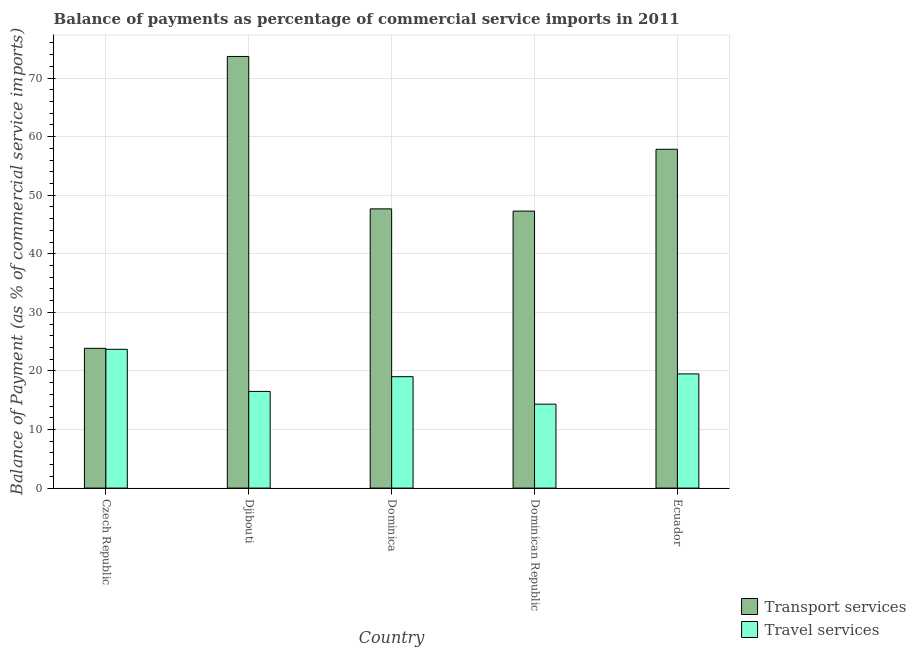How many different coloured bars are there?
Make the answer very short. 2. How many groups of bars are there?
Give a very brief answer. 5. Are the number of bars on each tick of the X-axis equal?
Your response must be concise. Yes. How many bars are there on the 4th tick from the right?
Keep it short and to the point. 2. What is the label of the 5th group of bars from the left?
Offer a very short reply. Ecuador. What is the balance of payments of travel services in Djibouti?
Keep it short and to the point. 16.5. Across all countries, what is the maximum balance of payments of transport services?
Ensure brevity in your answer.  73.68. Across all countries, what is the minimum balance of payments of travel services?
Keep it short and to the point. 14.33. In which country was the balance of payments of travel services maximum?
Your answer should be compact. Czech Republic. In which country was the balance of payments of travel services minimum?
Keep it short and to the point. Dominican Republic. What is the total balance of payments of transport services in the graph?
Your response must be concise. 250.31. What is the difference between the balance of payments of transport services in Czech Republic and that in Ecuador?
Your answer should be compact. -33.98. What is the difference between the balance of payments of travel services in Djibouti and the balance of payments of transport services in Dominican Republic?
Make the answer very short. -30.78. What is the average balance of payments of travel services per country?
Provide a short and direct response. 18.61. What is the difference between the balance of payments of transport services and balance of payments of travel services in Ecuador?
Your answer should be very brief. 38.34. What is the ratio of the balance of payments of travel services in Dominican Republic to that in Ecuador?
Make the answer very short. 0.74. Is the balance of payments of transport services in Dominica less than that in Ecuador?
Provide a short and direct response. Yes. What is the difference between the highest and the second highest balance of payments of transport services?
Keep it short and to the point. 15.84. What is the difference between the highest and the lowest balance of payments of travel services?
Offer a very short reply. 9.37. What does the 1st bar from the left in Ecuador represents?
Provide a short and direct response. Transport services. What does the 2nd bar from the right in Djibouti represents?
Make the answer very short. Transport services. How many countries are there in the graph?
Offer a very short reply. 5. What is the difference between two consecutive major ticks on the Y-axis?
Your response must be concise. 10. Does the graph contain grids?
Offer a terse response. Yes. How many legend labels are there?
Provide a short and direct response. 2. How are the legend labels stacked?
Make the answer very short. Vertical. What is the title of the graph?
Your answer should be very brief. Balance of payments as percentage of commercial service imports in 2011. What is the label or title of the Y-axis?
Your answer should be very brief. Balance of Payment (as % of commercial service imports). What is the Balance of Payment (as % of commercial service imports) in Transport services in Czech Republic?
Provide a succinct answer. 23.86. What is the Balance of Payment (as % of commercial service imports) in Travel services in Czech Republic?
Your response must be concise. 23.69. What is the Balance of Payment (as % of commercial service imports) of Transport services in Djibouti?
Offer a very short reply. 73.68. What is the Balance of Payment (as % of commercial service imports) of Travel services in Djibouti?
Offer a terse response. 16.5. What is the Balance of Payment (as % of commercial service imports) of Transport services in Dominica?
Offer a terse response. 47.66. What is the Balance of Payment (as % of commercial service imports) in Travel services in Dominica?
Give a very brief answer. 19.02. What is the Balance of Payment (as % of commercial service imports) of Transport services in Dominican Republic?
Your response must be concise. 47.28. What is the Balance of Payment (as % of commercial service imports) in Travel services in Dominican Republic?
Your answer should be very brief. 14.33. What is the Balance of Payment (as % of commercial service imports) in Transport services in Ecuador?
Offer a terse response. 57.83. What is the Balance of Payment (as % of commercial service imports) in Travel services in Ecuador?
Offer a very short reply. 19.49. Across all countries, what is the maximum Balance of Payment (as % of commercial service imports) of Transport services?
Give a very brief answer. 73.68. Across all countries, what is the maximum Balance of Payment (as % of commercial service imports) in Travel services?
Ensure brevity in your answer.  23.69. Across all countries, what is the minimum Balance of Payment (as % of commercial service imports) of Transport services?
Your response must be concise. 23.86. Across all countries, what is the minimum Balance of Payment (as % of commercial service imports) in Travel services?
Offer a very short reply. 14.33. What is the total Balance of Payment (as % of commercial service imports) in Transport services in the graph?
Your response must be concise. 250.31. What is the total Balance of Payment (as % of commercial service imports) of Travel services in the graph?
Your answer should be very brief. 93.03. What is the difference between the Balance of Payment (as % of commercial service imports) of Transport services in Czech Republic and that in Djibouti?
Offer a terse response. -49.82. What is the difference between the Balance of Payment (as % of commercial service imports) in Travel services in Czech Republic and that in Djibouti?
Keep it short and to the point. 7.19. What is the difference between the Balance of Payment (as % of commercial service imports) of Transport services in Czech Republic and that in Dominica?
Make the answer very short. -23.8. What is the difference between the Balance of Payment (as % of commercial service imports) of Travel services in Czech Republic and that in Dominica?
Your answer should be compact. 4.67. What is the difference between the Balance of Payment (as % of commercial service imports) of Transport services in Czech Republic and that in Dominican Republic?
Ensure brevity in your answer.  -23.42. What is the difference between the Balance of Payment (as % of commercial service imports) of Travel services in Czech Republic and that in Dominican Republic?
Ensure brevity in your answer.  9.37. What is the difference between the Balance of Payment (as % of commercial service imports) of Transport services in Czech Republic and that in Ecuador?
Your answer should be very brief. -33.98. What is the difference between the Balance of Payment (as % of commercial service imports) of Travel services in Czech Republic and that in Ecuador?
Make the answer very short. 4.2. What is the difference between the Balance of Payment (as % of commercial service imports) in Transport services in Djibouti and that in Dominica?
Provide a succinct answer. 26.02. What is the difference between the Balance of Payment (as % of commercial service imports) of Travel services in Djibouti and that in Dominica?
Provide a succinct answer. -2.51. What is the difference between the Balance of Payment (as % of commercial service imports) in Transport services in Djibouti and that in Dominican Republic?
Provide a succinct answer. 26.4. What is the difference between the Balance of Payment (as % of commercial service imports) of Travel services in Djibouti and that in Dominican Republic?
Offer a terse response. 2.18. What is the difference between the Balance of Payment (as % of commercial service imports) of Transport services in Djibouti and that in Ecuador?
Offer a very short reply. 15.84. What is the difference between the Balance of Payment (as % of commercial service imports) in Travel services in Djibouti and that in Ecuador?
Provide a succinct answer. -2.99. What is the difference between the Balance of Payment (as % of commercial service imports) of Transport services in Dominica and that in Dominican Republic?
Ensure brevity in your answer.  0.38. What is the difference between the Balance of Payment (as % of commercial service imports) in Travel services in Dominica and that in Dominican Republic?
Your response must be concise. 4.69. What is the difference between the Balance of Payment (as % of commercial service imports) of Transport services in Dominica and that in Ecuador?
Keep it short and to the point. -10.17. What is the difference between the Balance of Payment (as % of commercial service imports) in Travel services in Dominica and that in Ecuador?
Your answer should be compact. -0.47. What is the difference between the Balance of Payment (as % of commercial service imports) of Transport services in Dominican Republic and that in Ecuador?
Make the answer very short. -10.55. What is the difference between the Balance of Payment (as % of commercial service imports) in Travel services in Dominican Republic and that in Ecuador?
Your response must be concise. -5.16. What is the difference between the Balance of Payment (as % of commercial service imports) of Transport services in Czech Republic and the Balance of Payment (as % of commercial service imports) of Travel services in Djibouti?
Keep it short and to the point. 7.36. What is the difference between the Balance of Payment (as % of commercial service imports) of Transport services in Czech Republic and the Balance of Payment (as % of commercial service imports) of Travel services in Dominica?
Your answer should be compact. 4.84. What is the difference between the Balance of Payment (as % of commercial service imports) in Transport services in Czech Republic and the Balance of Payment (as % of commercial service imports) in Travel services in Dominican Republic?
Give a very brief answer. 9.53. What is the difference between the Balance of Payment (as % of commercial service imports) of Transport services in Czech Republic and the Balance of Payment (as % of commercial service imports) of Travel services in Ecuador?
Your response must be concise. 4.37. What is the difference between the Balance of Payment (as % of commercial service imports) of Transport services in Djibouti and the Balance of Payment (as % of commercial service imports) of Travel services in Dominica?
Provide a short and direct response. 54.66. What is the difference between the Balance of Payment (as % of commercial service imports) in Transport services in Djibouti and the Balance of Payment (as % of commercial service imports) in Travel services in Dominican Republic?
Ensure brevity in your answer.  59.35. What is the difference between the Balance of Payment (as % of commercial service imports) in Transport services in Djibouti and the Balance of Payment (as % of commercial service imports) in Travel services in Ecuador?
Provide a succinct answer. 54.19. What is the difference between the Balance of Payment (as % of commercial service imports) of Transport services in Dominica and the Balance of Payment (as % of commercial service imports) of Travel services in Dominican Republic?
Offer a terse response. 33.34. What is the difference between the Balance of Payment (as % of commercial service imports) of Transport services in Dominica and the Balance of Payment (as % of commercial service imports) of Travel services in Ecuador?
Keep it short and to the point. 28.17. What is the difference between the Balance of Payment (as % of commercial service imports) in Transport services in Dominican Republic and the Balance of Payment (as % of commercial service imports) in Travel services in Ecuador?
Your answer should be very brief. 27.79. What is the average Balance of Payment (as % of commercial service imports) of Transport services per country?
Ensure brevity in your answer.  50.06. What is the average Balance of Payment (as % of commercial service imports) of Travel services per country?
Your answer should be compact. 18.61. What is the difference between the Balance of Payment (as % of commercial service imports) in Transport services and Balance of Payment (as % of commercial service imports) in Travel services in Czech Republic?
Keep it short and to the point. 0.17. What is the difference between the Balance of Payment (as % of commercial service imports) in Transport services and Balance of Payment (as % of commercial service imports) in Travel services in Djibouti?
Ensure brevity in your answer.  57.18. What is the difference between the Balance of Payment (as % of commercial service imports) of Transport services and Balance of Payment (as % of commercial service imports) of Travel services in Dominica?
Offer a terse response. 28.65. What is the difference between the Balance of Payment (as % of commercial service imports) of Transport services and Balance of Payment (as % of commercial service imports) of Travel services in Dominican Republic?
Your answer should be compact. 32.96. What is the difference between the Balance of Payment (as % of commercial service imports) of Transport services and Balance of Payment (as % of commercial service imports) of Travel services in Ecuador?
Your response must be concise. 38.34. What is the ratio of the Balance of Payment (as % of commercial service imports) in Transport services in Czech Republic to that in Djibouti?
Keep it short and to the point. 0.32. What is the ratio of the Balance of Payment (as % of commercial service imports) of Travel services in Czech Republic to that in Djibouti?
Your answer should be compact. 1.44. What is the ratio of the Balance of Payment (as % of commercial service imports) of Transport services in Czech Republic to that in Dominica?
Make the answer very short. 0.5. What is the ratio of the Balance of Payment (as % of commercial service imports) in Travel services in Czech Republic to that in Dominica?
Your answer should be compact. 1.25. What is the ratio of the Balance of Payment (as % of commercial service imports) in Transport services in Czech Republic to that in Dominican Republic?
Offer a terse response. 0.5. What is the ratio of the Balance of Payment (as % of commercial service imports) of Travel services in Czech Republic to that in Dominican Republic?
Keep it short and to the point. 1.65. What is the ratio of the Balance of Payment (as % of commercial service imports) in Transport services in Czech Republic to that in Ecuador?
Your response must be concise. 0.41. What is the ratio of the Balance of Payment (as % of commercial service imports) of Travel services in Czech Republic to that in Ecuador?
Your answer should be very brief. 1.22. What is the ratio of the Balance of Payment (as % of commercial service imports) in Transport services in Djibouti to that in Dominica?
Give a very brief answer. 1.55. What is the ratio of the Balance of Payment (as % of commercial service imports) of Travel services in Djibouti to that in Dominica?
Keep it short and to the point. 0.87. What is the ratio of the Balance of Payment (as % of commercial service imports) in Transport services in Djibouti to that in Dominican Republic?
Make the answer very short. 1.56. What is the ratio of the Balance of Payment (as % of commercial service imports) in Travel services in Djibouti to that in Dominican Republic?
Give a very brief answer. 1.15. What is the ratio of the Balance of Payment (as % of commercial service imports) of Transport services in Djibouti to that in Ecuador?
Keep it short and to the point. 1.27. What is the ratio of the Balance of Payment (as % of commercial service imports) of Travel services in Djibouti to that in Ecuador?
Make the answer very short. 0.85. What is the ratio of the Balance of Payment (as % of commercial service imports) in Transport services in Dominica to that in Dominican Republic?
Your response must be concise. 1.01. What is the ratio of the Balance of Payment (as % of commercial service imports) in Travel services in Dominica to that in Dominican Republic?
Offer a terse response. 1.33. What is the ratio of the Balance of Payment (as % of commercial service imports) of Transport services in Dominica to that in Ecuador?
Your response must be concise. 0.82. What is the ratio of the Balance of Payment (as % of commercial service imports) in Travel services in Dominica to that in Ecuador?
Offer a very short reply. 0.98. What is the ratio of the Balance of Payment (as % of commercial service imports) in Transport services in Dominican Republic to that in Ecuador?
Ensure brevity in your answer.  0.82. What is the ratio of the Balance of Payment (as % of commercial service imports) in Travel services in Dominican Republic to that in Ecuador?
Your answer should be compact. 0.74. What is the difference between the highest and the second highest Balance of Payment (as % of commercial service imports) in Transport services?
Offer a very short reply. 15.84. What is the difference between the highest and the second highest Balance of Payment (as % of commercial service imports) of Travel services?
Provide a succinct answer. 4.2. What is the difference between the highest and the lowest Balance of Payment (as % of commercial service imports) of Transport services?
Offer a terse response. 49.82. What is the difference between the highest and the lowest Balance of Payment (as % of commercial service imports) in Travel services?
Your response must be concise. 9.37. 